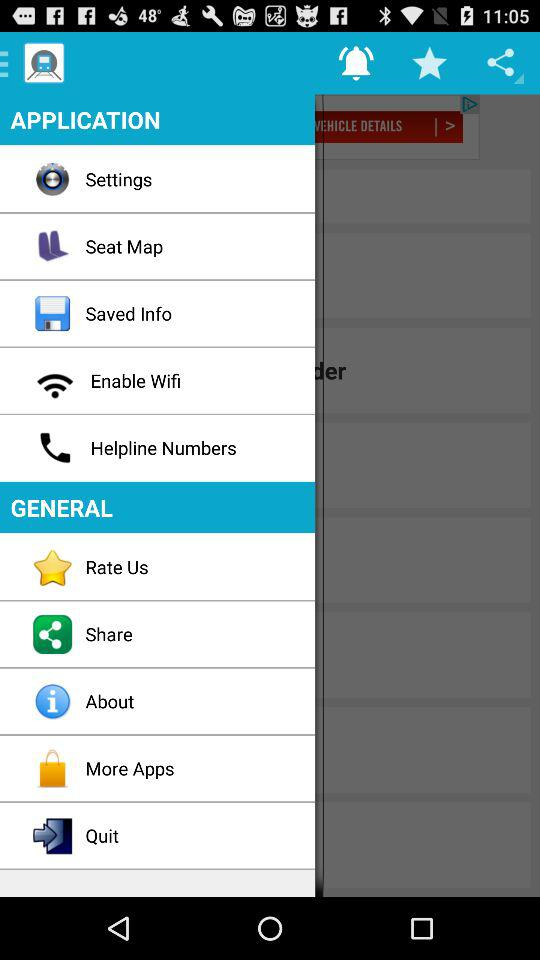What is the application name?
When the provided information is insufficient, respond with <no answer>. <no answer> 